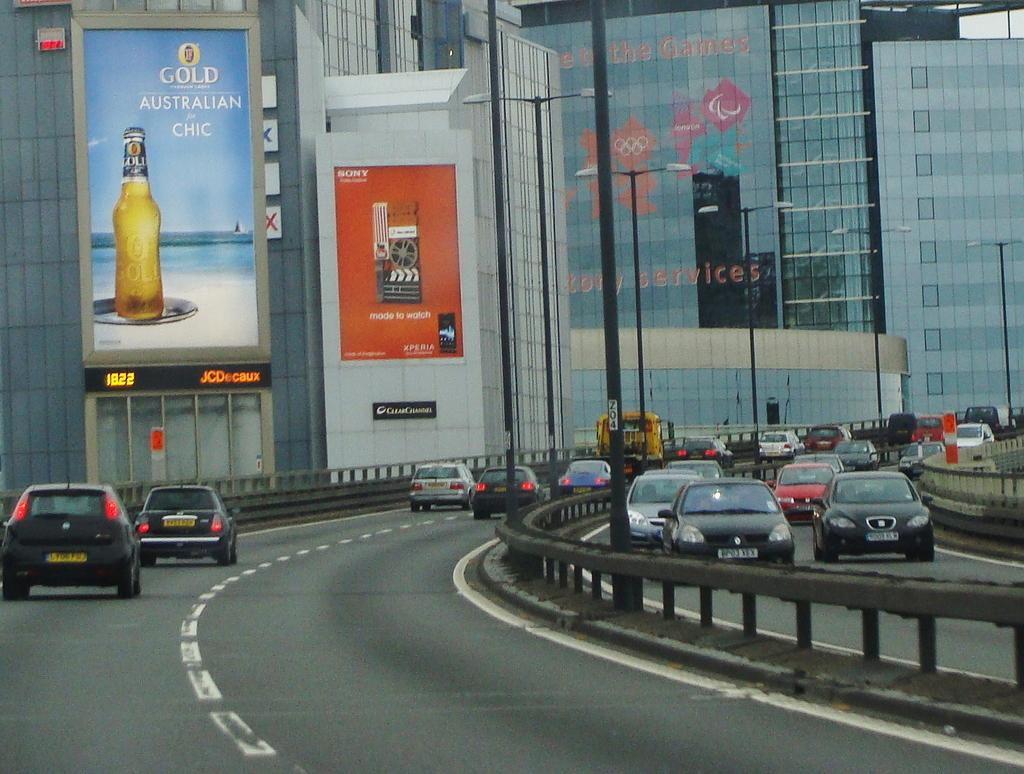What can be seen moving on the roads in the image? There are vehicles on the roads in the image. What type of structures are present to provide safety or support in the image? Railings and poles are present in the image. What type of lighting is visible in the image? Street lights are visible in the image. What can be seen in the background of the image? There are buildings, banners, and glass objects in the background of the image. What type of education is being taught in the image? There is no indication of education being taught in the image. What shape is the square in the image? There is no square present in the image. What type of yarn is being used to create the banners in the image? The banners in the image are not made of yarn; they are likely made of fabric or paper. 